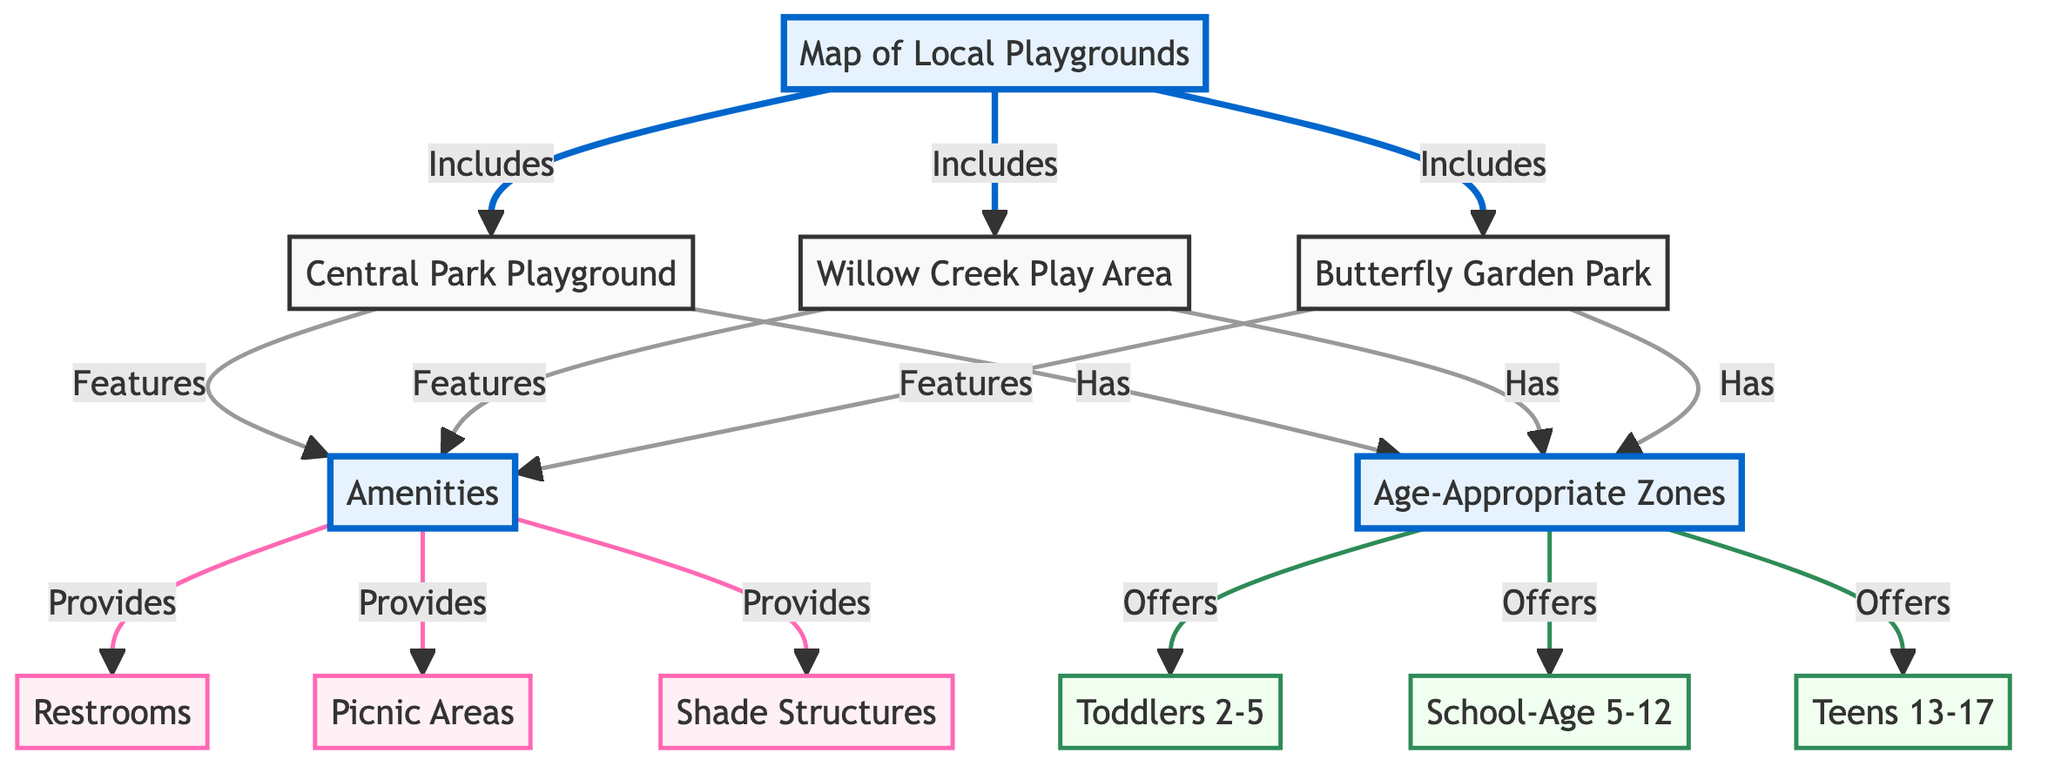What are the names of the playgrounds included in the map? The diagram explicitly lists three playgrounds: Central Park Playground, Willow Creek Play Area, and Butterfly Garden Park, connected to the main "Map of Local Playgrounds".
Answer: Central Park Playground, Willow Creek Play Area, Butterfly Garden Park How many types of amenities are provided in the playgrounds? The diagram shows three types of amenities: Restrooms, Picnic Areas, and Shade Structures, under the "Amenities" node. Therefore, the count is three.
Answer: 3 Which age groups are catered to by the playgrounds? The playgrounds cater to three specific age groups: Toddlers 2-5, School-Age 5-12, and Teens 13-17 as shown in the "Age-Appropriate Zones" section of the diagram.
Answer: Toddlers 2-5, School-Age 5-12, Teens 13-17 What amenities are available in all playgrounds? The diagram indicates that all playgrounds feature the listed amenities: Restrooms, Picnic Areas, and Shade Structures. Each is connected to the playground nodes.
Answer: Restrooms, Picnic Areas, Shade Structures How many total nodes are displayed in the diagram? The diagram has a total of 12 nodes, which includes the main nodes for "Map of Local Playgrounds", "Amenities", "Age-Appropriate Zones", and the individual nodes for playgrounds, amenities, and age groups.
Answer: 12 Which playground is linked to all the provided amenities? Each playground, specifically the Central Park Playground, Willow Creek Play Area, and Butterfly Garden Park, is connected to the "Amenities" node, which indicates that they all offer the amenities listed.
Answer: Central Park Playground, Willow Creek Play Area, Butterfly Garden Park What is the relationship between age groups and playgrounds? The "Age-Appropriate Zones" node indicates that the playgrounds are directly linked to specific age groups (Toddlers, School-Age, Teens), meaning they are designed to cater to these ages within the defined playgrounds.
Answer: They are directly linked Which zone is designated for toddlers? In the diagram, the age group designated for toddlers is specifically labeled as “Toddlers 2-5” under the "Age-Appropriate Zones" node.
Answer: Toddlers 2-5 